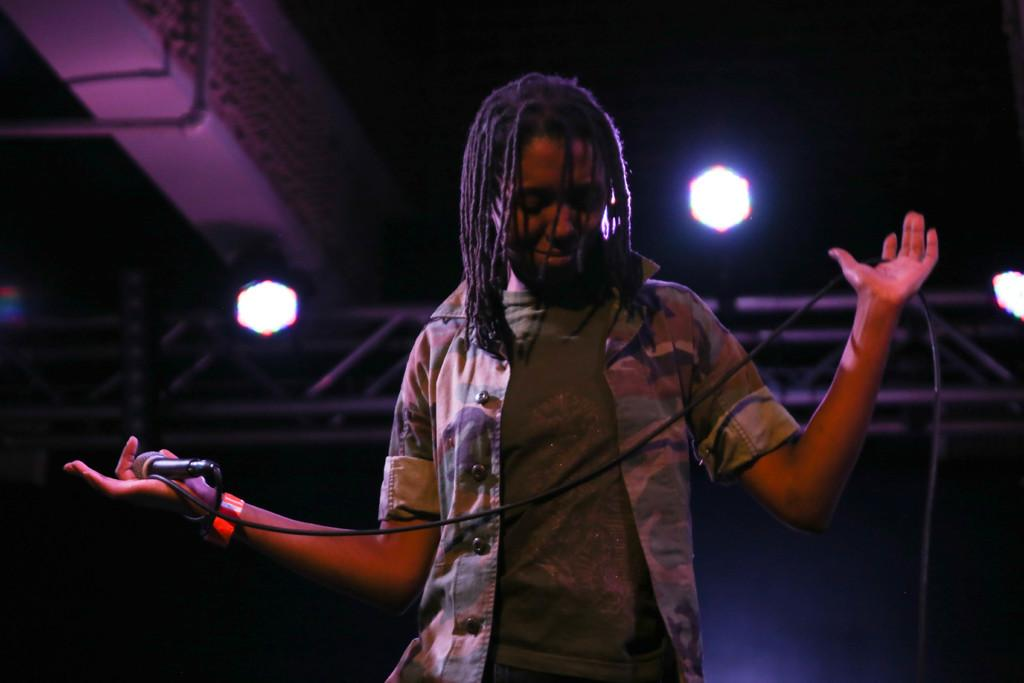What is the main subject of the image? There is a person in the image. What is the person doing in the image? The person is standing and holding a mic in his hands. Are there any other objects or features in the image? Yes, there are two lights behind the person. What type of bath can be seen in the image? There is no bath present in the image. Is the person in the image a crook or a believer? The image does not provide any information about the person's character or beliefs. 